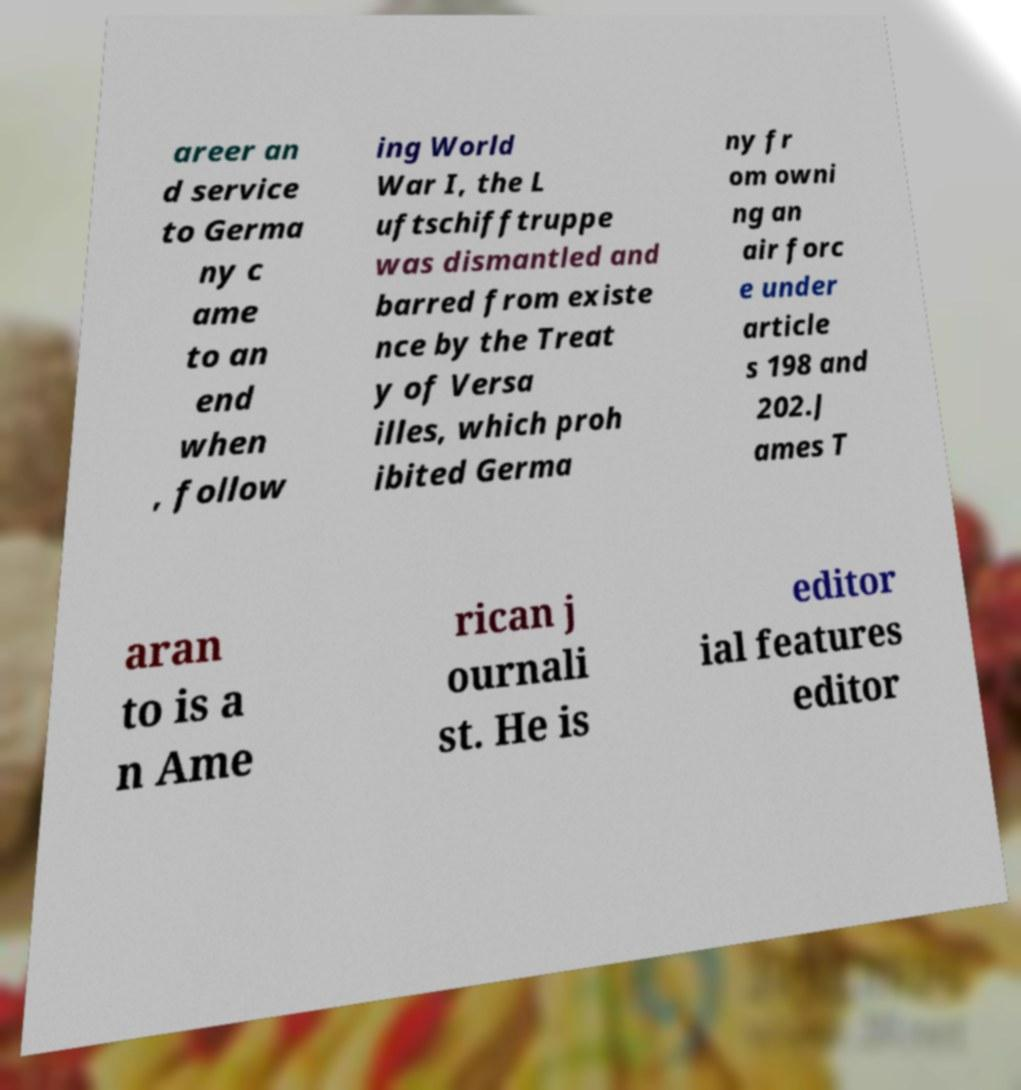There's text embedded in this image that I need extracted. Can you transcribe it verbatim? areer an d service to Germa ny c ame to an end when , follow ing World War I, the L uftschifftruppe was dismantled and barred from existe nce by the Treat y of Versa illes, which proh ibited Germa ny fr om owni ng an air forc e under article s 198 and 202.J ames T aran to is a n Ame rican j ournali st. He is editor ial features editor 